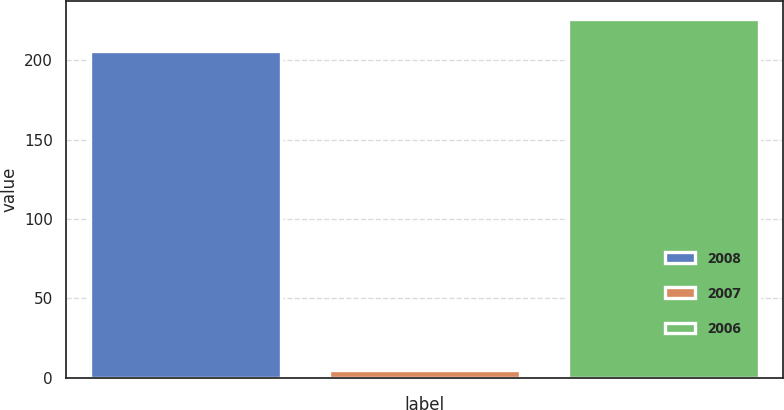Convert chart to OTSL. <chart><loc_0><loc_0><loc_500><loc_500><bar_chart><fcel>2008<fcel>2007<fcel>2006<nl><fcel>206<fcel>5<fcel>226.2<nl></chart> 